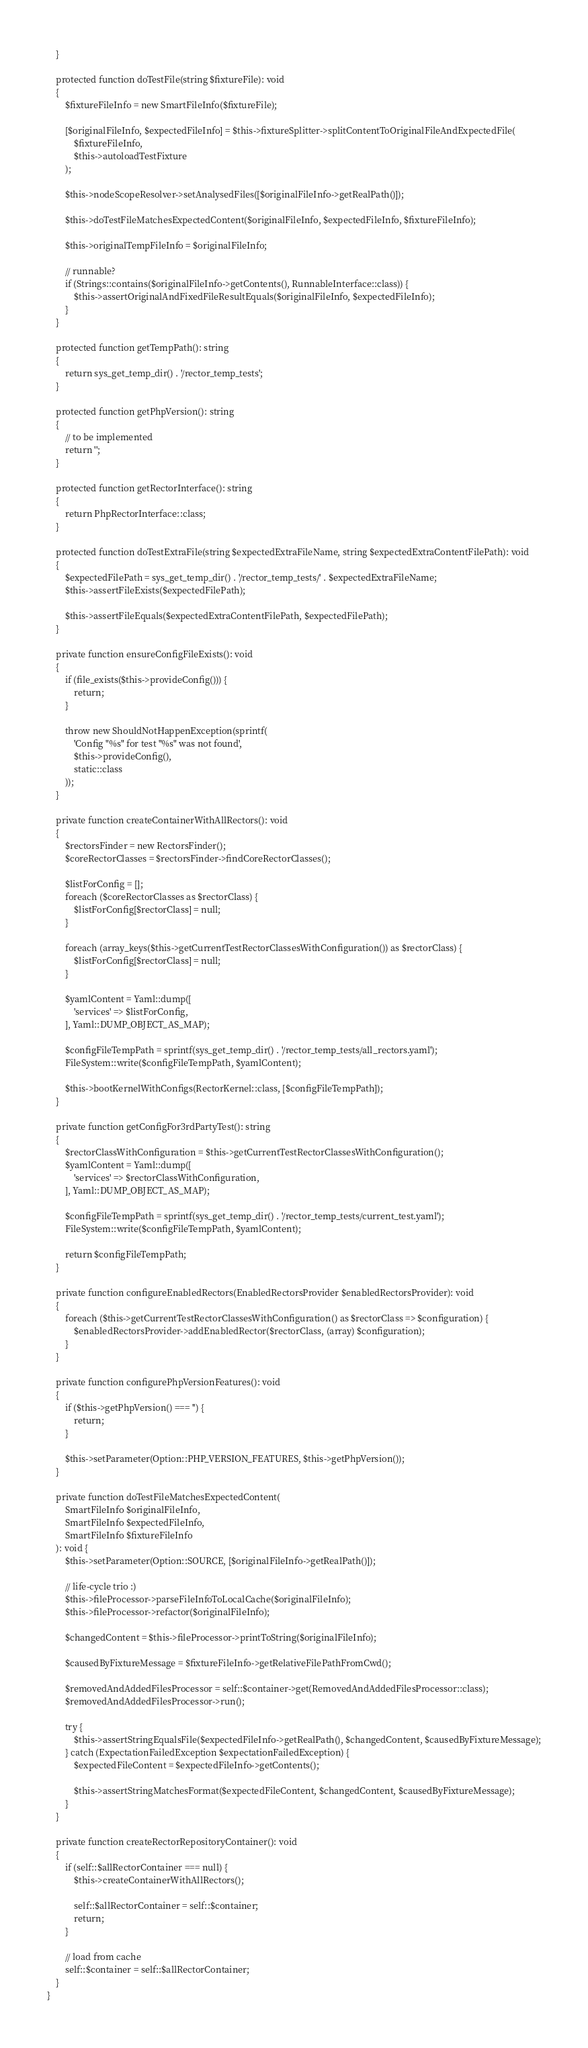<code> <loc_0><loc_0><loc_500><loc_500><_PHP_>    }

    protected function doTestFile(string $fixtureFile): void
    {
        $fixtureFileInfo = new SmartFileInfo($fixtureFile);

        [$originalFileInfo, $expectedFileInfo] = $this->fixtureSplitter->splitContentToOriginalFileAndExpectedFile(
            $fixtureFileInfo,
            $this->autoloadTestFixture
        );

        $this->nodeScopeResolver->setAnalysedFiles([$originalFileInfo->getRealPath()]);

        $this->doTestFileMatchesExpectedContent($originalFileInfo, $expectedFileInfo, $fixtureFileInfo);

        $this->originalTempFileInfo = $originalFileInfo;

        // runnable?
        if (Strings::contains($originalFileInfo->getContents(), RunnableInterface::class)) {
            $this->assertOriginalAndFixedFileResultEquals($originalFileInfo, $expectedFileInfo);
        }
    }

    protected function getTempPath(): string
    {
        return sys_get_temp_dir() . '/rector_temp_tests';
    }

    protected function getPhpVersion(): string
    {
        // to be implemented
        return '';
    }

    protected function getRectorInterface(): string
    {
        return PhpRectorInterface::class;
    }

    protected function doTestExtraFile(string $expectedExtraFileName, string $expectedExtraContentFilePath): void
    {
        $expectedFilePath = sys_get_temp_dir() . '/rector_temp_tests/' . $expectedExtraFileName;
        $this->assertFileExists($expectedFilePath);

        $this->assertFileEquals($expectedExtraContentFilePath, $expectedFilePath);
    }

    private function ensureConfigFileExists(): void
    {
        if (file_exists($this->provideConfig())) {
            return;
        }

        throw new ShouldNotHappenException(sprintf(
            'Config "%s" for test "%s" was not found',
            $this->provideConfig(),
            static::class
        ));
    }

    private function createContainerWithAllRectors(): void
    {
        $rectorsFinder = new RectorsFinder();
        $coreRectorClasses = $rectorsFinder->findCoreRectorClasses();

        $listForConfig = [];
        foreach ($coreRectorClasses as $rectorClass) {
            $listForConfig[$rectorClass] = null;
        }

        foreach (array_keys($this->getCurrentTestRectorClassesWithConfiguration()) as $rectorClass) {
            $listForConfig[$rectorClass] = null;
        }

        $yamlContent = Yaml::dump([
            'services' => $listForConfig,
        ], Yaml::DUMP_OBJECT_AS_MAP);

        $configFileTempPath = sprintf(sys_get_temp_dir() . '/rector_temp_tests/all_rectors.yaml');
        FileSystem::write($configFileTempPath, $yamlContent);

        $this->bootKernelWithConfigs(RectorKernel::class, [$configFileTempPath]);
    }

    private function getConfigFor3rdPartyTest(): string
    {
        $rectorClassWithConfiguration = $this->getCurrentTestRectorClassesWithConfiguration();
        $yamlContent = Yaml::dump([
            'services' => $rectorClassWithConfiguration,
        ], Yaml::DUMP_OBJECT_AS_MAP);

        $configFileTempPath = sprintf(sys_get_temp_dir() . '/rector_temp_tests/current_test.yaml');
        FileSystem::write($configFileTempPath, $yamlContent);

        return $configFileTempPath;
    }

    private function configureEnabledRectors(EnabledRectorsProvider $enabledRectorsProvider): void
    {
        foreach ($this->getCurrentTestRectorClassesWithConfiguration() as $rectorClass => $configuration) {
            $enabledRectorsProvider->addEnabledRector($rectorClass, (array) $configuration);
        }
    }

    private function configurePhpVersionFeatures(): void
    {
        if ($this->getPhpVersion() === '') {
            return;
        }

        $this->setParameter(Option::PHP_VERSION_FEATURES, $this->getPhpVersion());
    }

    private function doTestFileMatchesExpectedContent(
        SmartFileInfo $originalFileInfo,
        SmartFileInfo $expectedFileInfo,
        SmartFileInfo $fixtureFileInfo
    ): void {
        $this->setParameter(Option::SOURCE, [$originalFileInfo->getRealPath()]);

        // life-cycle trio :)
        $this->fileProcessor->parseFileInfoToLocalCache($originalFileInfo);
        $this->fileProcessor->refactor($originalFileInfo);

        $changedContent = $this->fileProcessor->printToString($originalFileInfo);

        $causedByFixtureMessage = $fixtureFileInfo->getRelativeFilePathFromCwd();

        $removedAndAddedFilesProcessor = self::$container->get(RemovedAndAddedFilesProcessor::class);
        $removedAndAddedFilesProcessor->run();

        try {
            $this->assertStringEqualsFile($expectedFileInfo->getRealPath(), $changedContent, $causedByFixtureMessage);
        } catch (ExpectationFailedException $expectationFailedException) {
            $expectedFileContent = $expectedFileInfo->getContents();

            $this->assertStringMatchesFormat($expectedFileContent, $changedContent, $causedByFixtureMessage);
        }
    }

    private function createRectorRepositoryContainer(): void
    {
        if (self::$allRectorContainer === null) {
            $this->createContainerWithAllRectors();

            self::$allRectorContainer = self::$container;
            return;
        }

        // load from cache
        self::$container = self::$allRectorContainer;
    }
}
</code> 